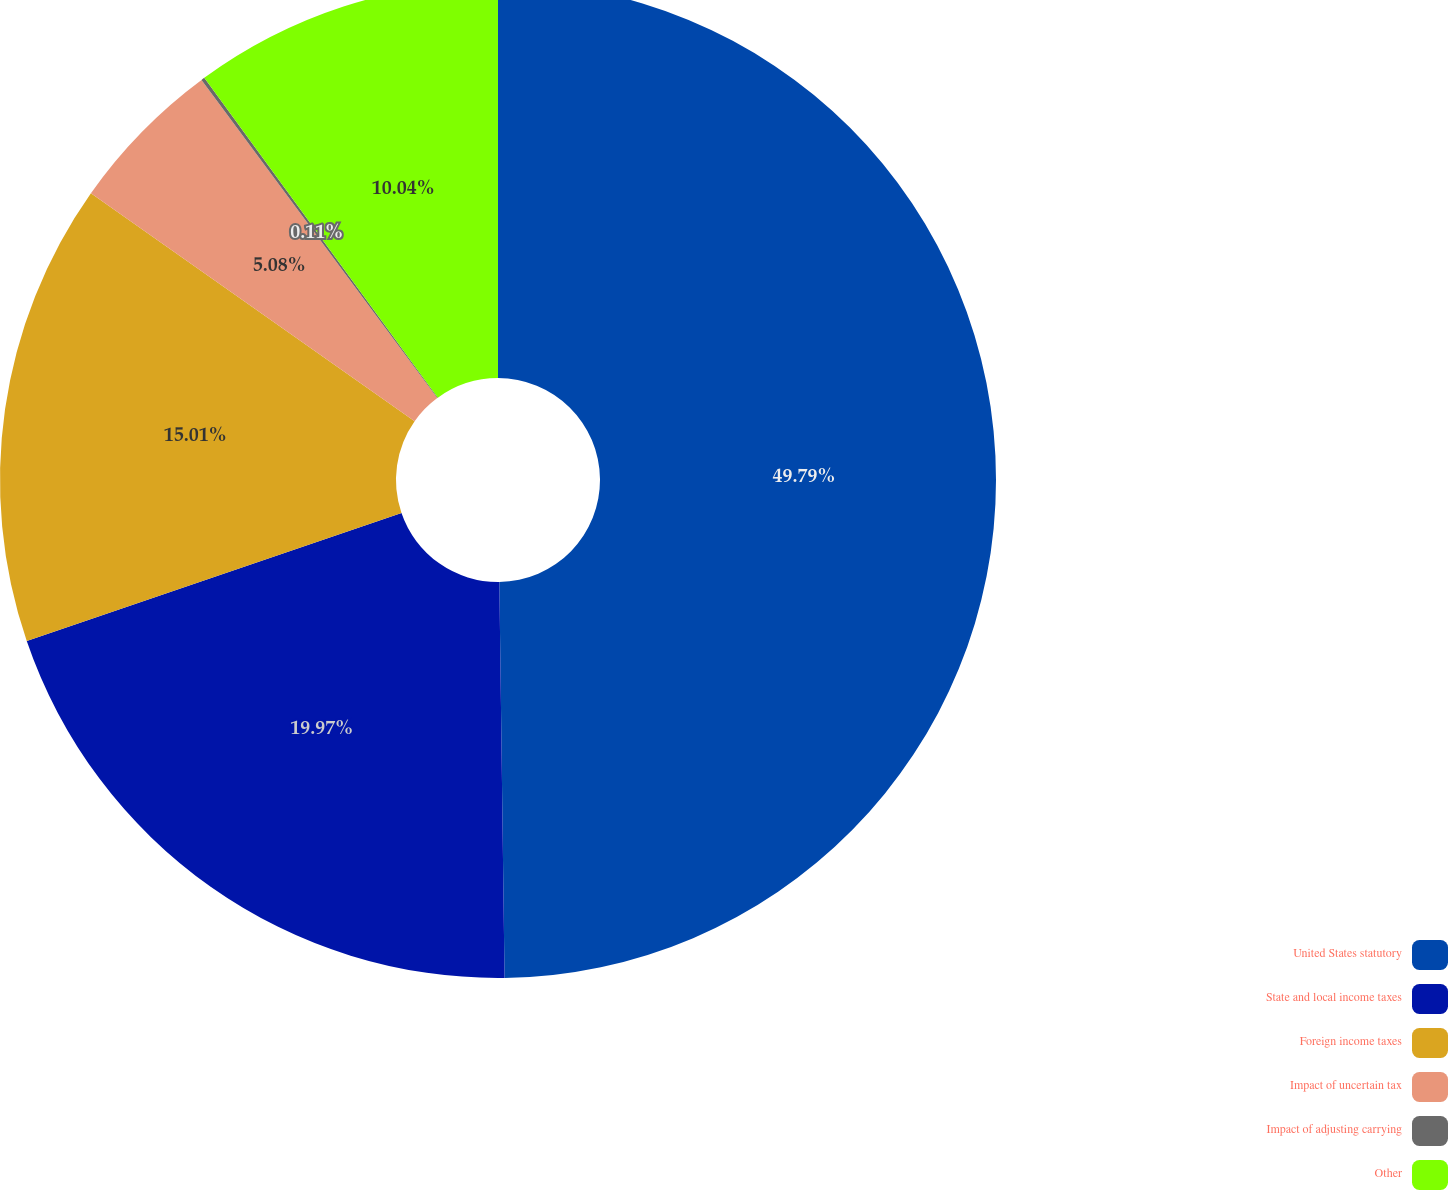Convert chart. <chart><loc_0><loc_0><loc_500><loc_500><pie_chart><fcel>United States statutory<fcel>State and local income taxes<fcel>Foreign income taxes<fcel>Impact of uncertain tax<fcel>Impact of adjusting carrying<fcel>Other<nl><fcel>49.79%<fcel>19.97%<fcel>15.01%<fcel>5.08%<fcel>0.11%<fcel>10.04%<nl></chart> 